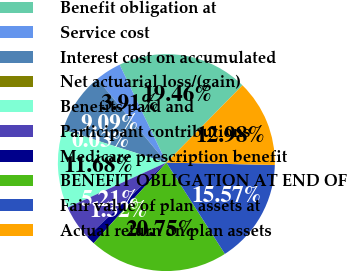Convert chart. <chart><loc_0><loc_0><loc_500><loc_500><pie_chart><fcel>Benefit obligation at<fcel>Service cost<fcel>Interest cost on accumulated<fcel>Net actuarial loss/(gain)<fcel>Benefits paid and<fcel>Participant contributions<fcel>Medicare prescription benefit<fcel>BENEFIT OBLIGATION AT END OF<fcel>Fair value of plan assets at<fcel>Actual return on plan assets<nl><fcel>19.46%<fcel>3.91%<fcel>9.09%<fcel>0.03%<fcel>11.68%<fcel>5.21%<fcel>1.32%<fcel>20.75%<fcel>15.57%<fcel>12.98%<nl></chart> 